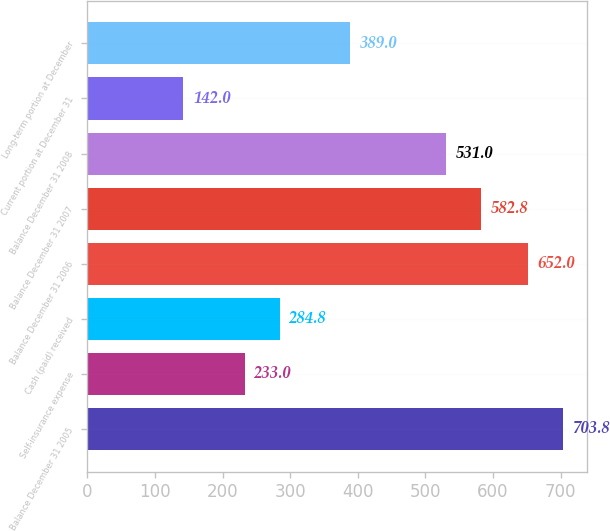Convert chart to OTSL. <chart><loc_0><loc_0><loc_500><loc_500><bar_chart><fcel>Balance December 31 2005<fcel>Self-insurance expense<fcel>Cash (paid) received<fcel>Balance December 31 2006<fcel>Balance December 31 2007<fcel>Balance December 31 2008<fcel>Current portion at December 31<fcel>Long-term portion at December<nl><fcel>703.8<fcel>233<fcel>284.8<fcel>652<fcel>582.8<fcel>531<fcel>142<fcel>389<nl></chart> 